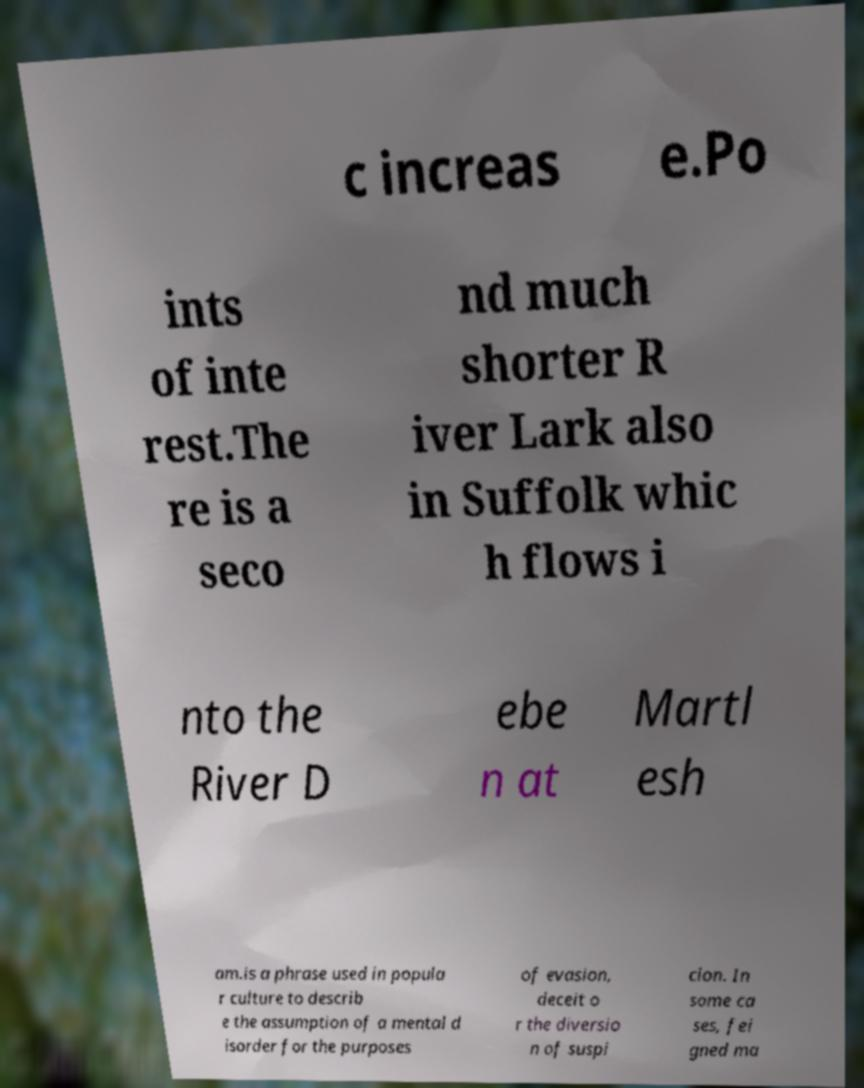There's text embedded in this image that I need extracted. Can you transcribe it verbatim? c increas e.Po ints of inte rest.The re is a seco nd much shorter R iver Lark also in Suffolk whic h flows i nto the River D ebe n at Martl esh am.is a phrase used in popula r culture to describ e the assumption of a mental d isorder for the purposes of evasion, deceit o r the diversio n of suspi cion. In some ca ses, fei gned ma 